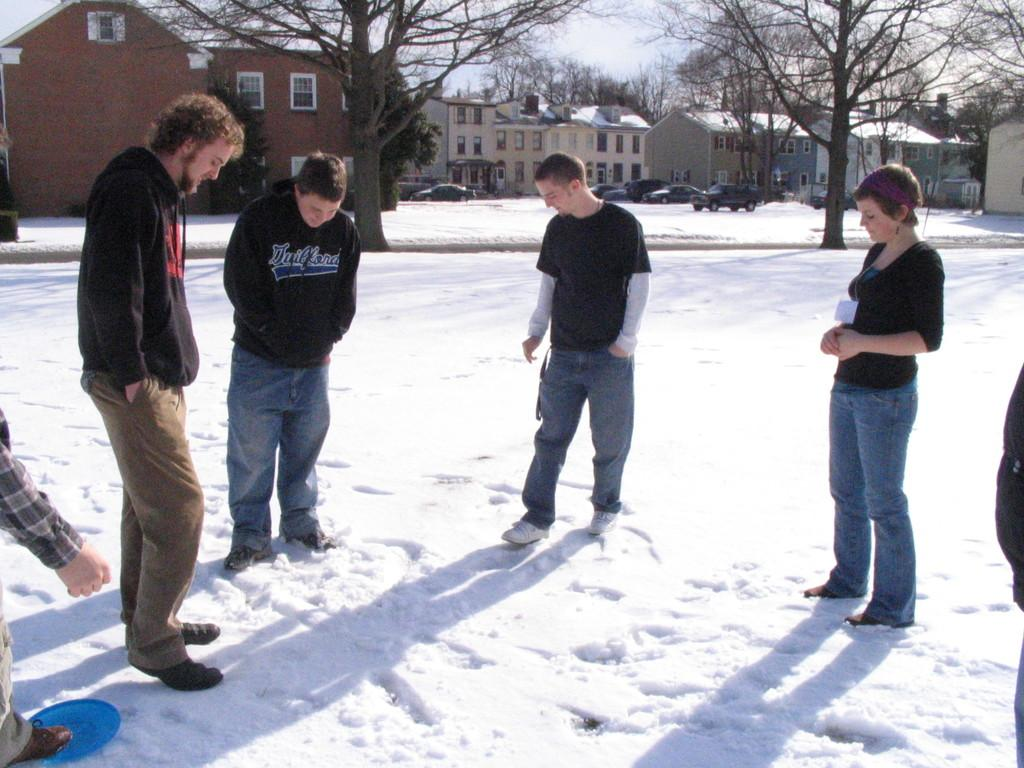What can be seen in the foreground of the image? There are people standing in the foreground of the image. What is visible in the background of the image? There are buildings, cars, and trees in the background of the image. What type of location is depicted in the image? This is a road. What is the weather like in the image? There is snow on the ground, indicating a snowy or cold weather condition. What type of pan can be seen hanging from the trees in the image? There is no pan present in the image; it features people, buildings, cars, trees, and snow on the ground. Is there a string attached to the cars in the image? There is no mention of a string in the image, which shows people, buildings, cars, trees, and snow on the ground. 